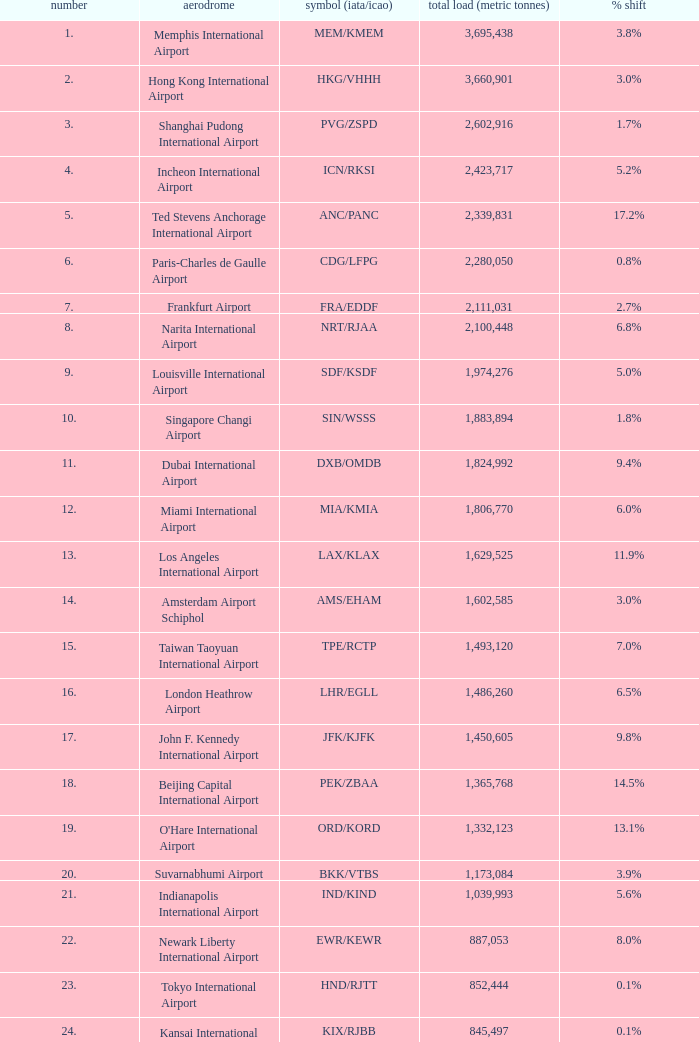What is the rank for ord/kord with more than 1,332,123 total cargo? None. 